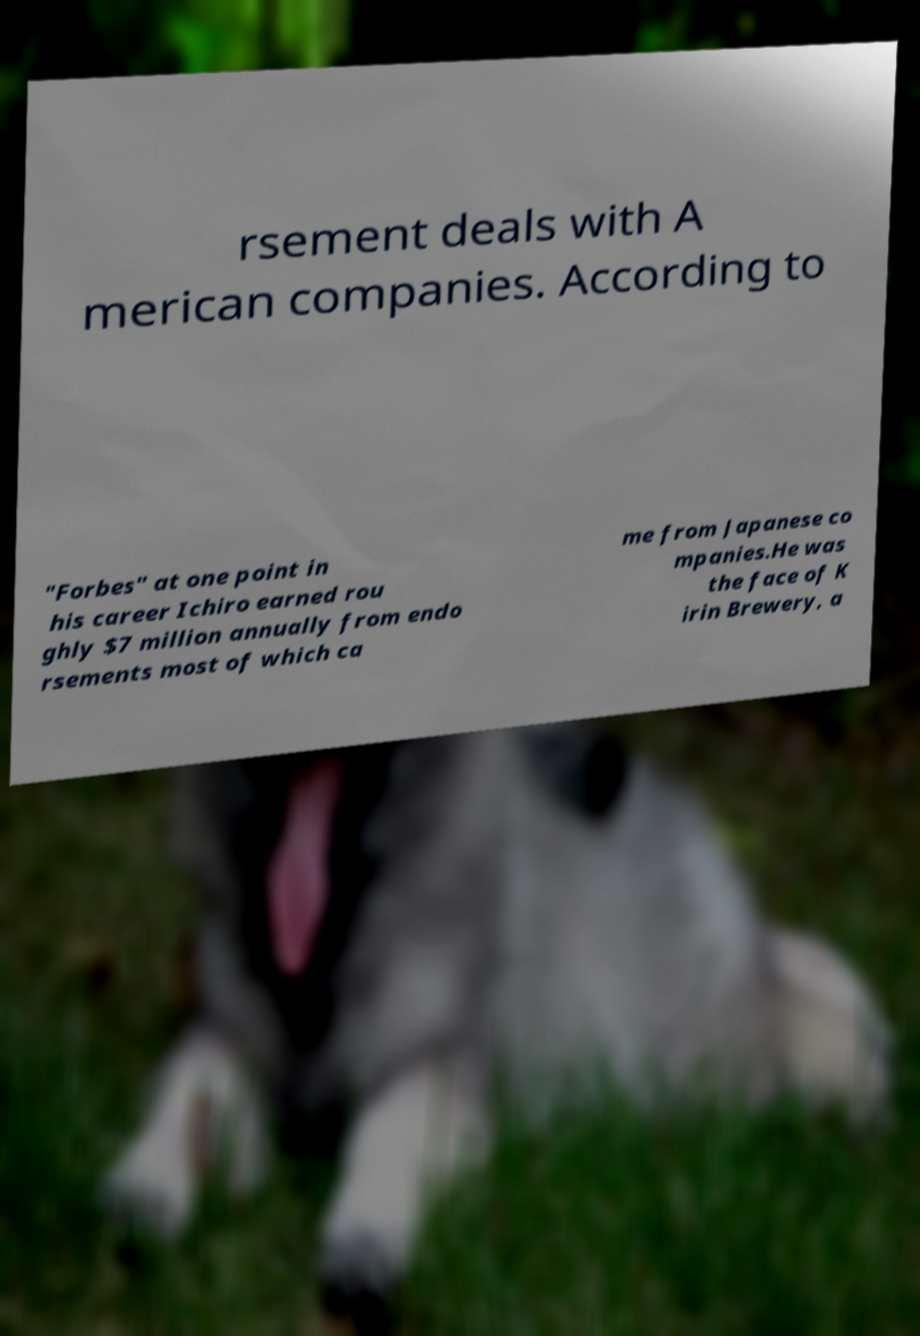What messages or text are displayed in this image? I need them in a readable, typed format. rsement deals with A merican companies. According to "Forbes" at one point in his career Ichiro earned rou ghly $7 million annually from endo rsements most of which ca me from Japanese co mpanies.He was the face of K irin Brewery, a 